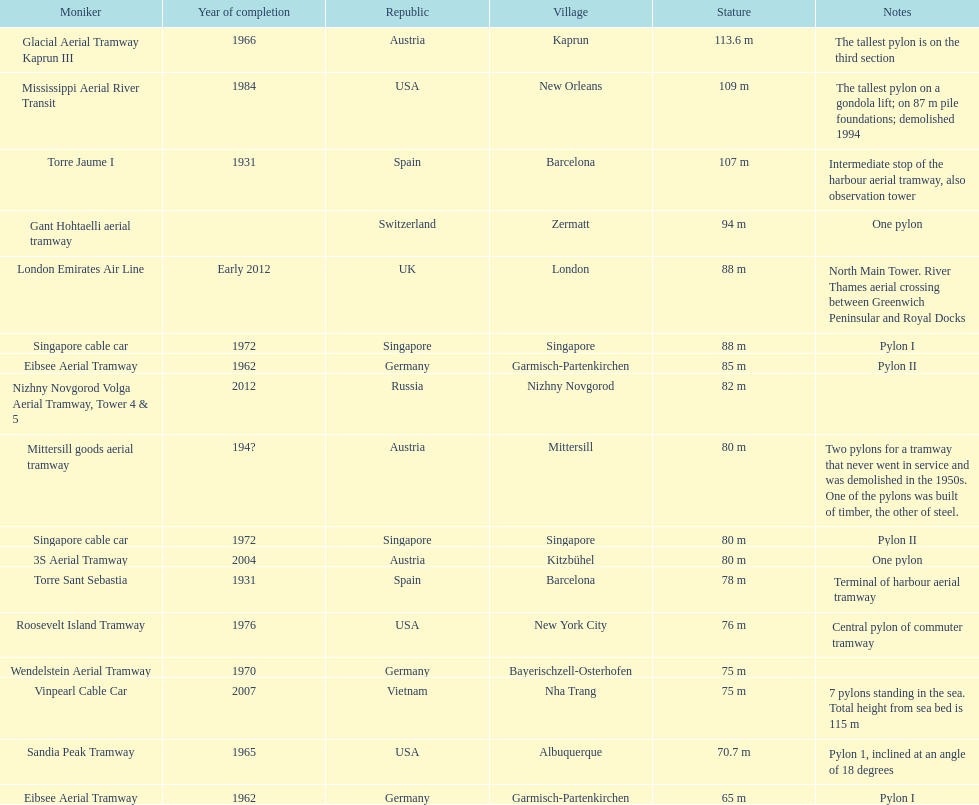Which pylon has the most comments regarding it? Mittersill goods aerial tramway. 